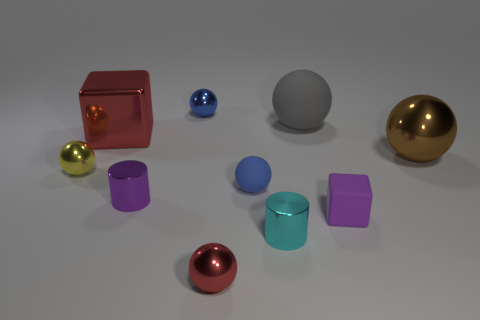Is there a red shiny thing in front of the tiny sphere that is left of the blue sphere that is behind the tiny yellow metallic sphere?
Offer a terse response. Yes. Does the red metal object in front of the purple cylinder have the same shape as the blue metal thing?
Give a very brief answer. Yes. What is the color of the large cube that is made of the same material as the yellow thing?
Provide a succinct answer. Red. How many tiny blue things have the same material as the small purple block?
Your answer should be very brief. 1. What is the color of the small rubber block in front of the metallic object right of the rubber thing behind the big brown metallic object?
Offer a terse response. Purple. Do the red ball and the gray ball have the same size?
Provide a short and direct response. No. Are there any other things that are the same shape as the tiny red metallic thing?
Provide a succinct answer. Yes. What number of things are either metal spheres that are to the right of the large matte object or big matte spheres?
Your answer should be compact. 2. Do the brown metal object and the tiny blue matte object have the same shape?
Your answer should be compact. Yes. What number of other things are there of the same size as the purple rubber object?
Keep it short and to the point. 6. 